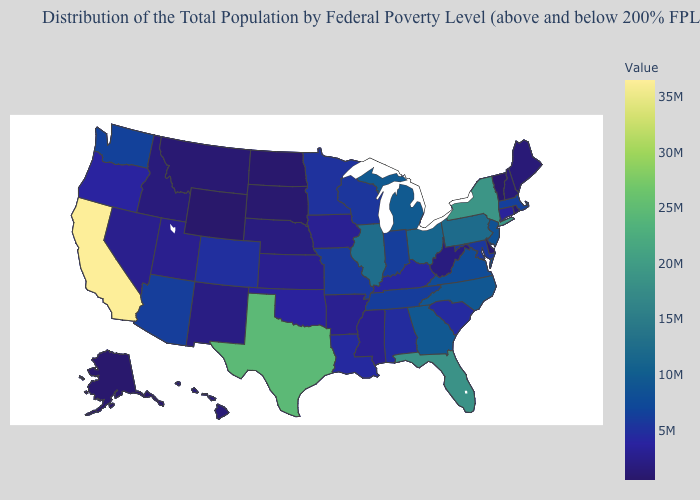Among the states that border Oklahoma , does Kansas have the highest value?
Keep it brief. No. Which states have the lowest value in the USA?
Short answer required. Wyoming. Is the legend a continuous bar?
Quick response, please. Yes. Does Vermont have the lowest value in the Northeast?
Concise answer only. Yes. Among the states that border Texas , does Arkansas have the lowest value?
Give a very brief answer. No. 